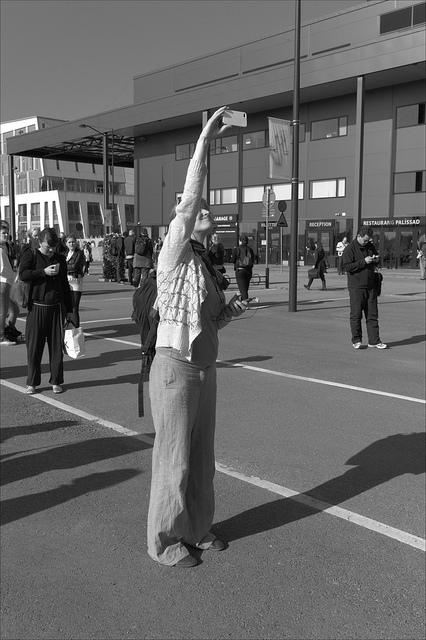Why is the woman holding her phone above her head?

Choices:
A) playing game
B) checking signal
C) watching video
D) taking photo taking photo 